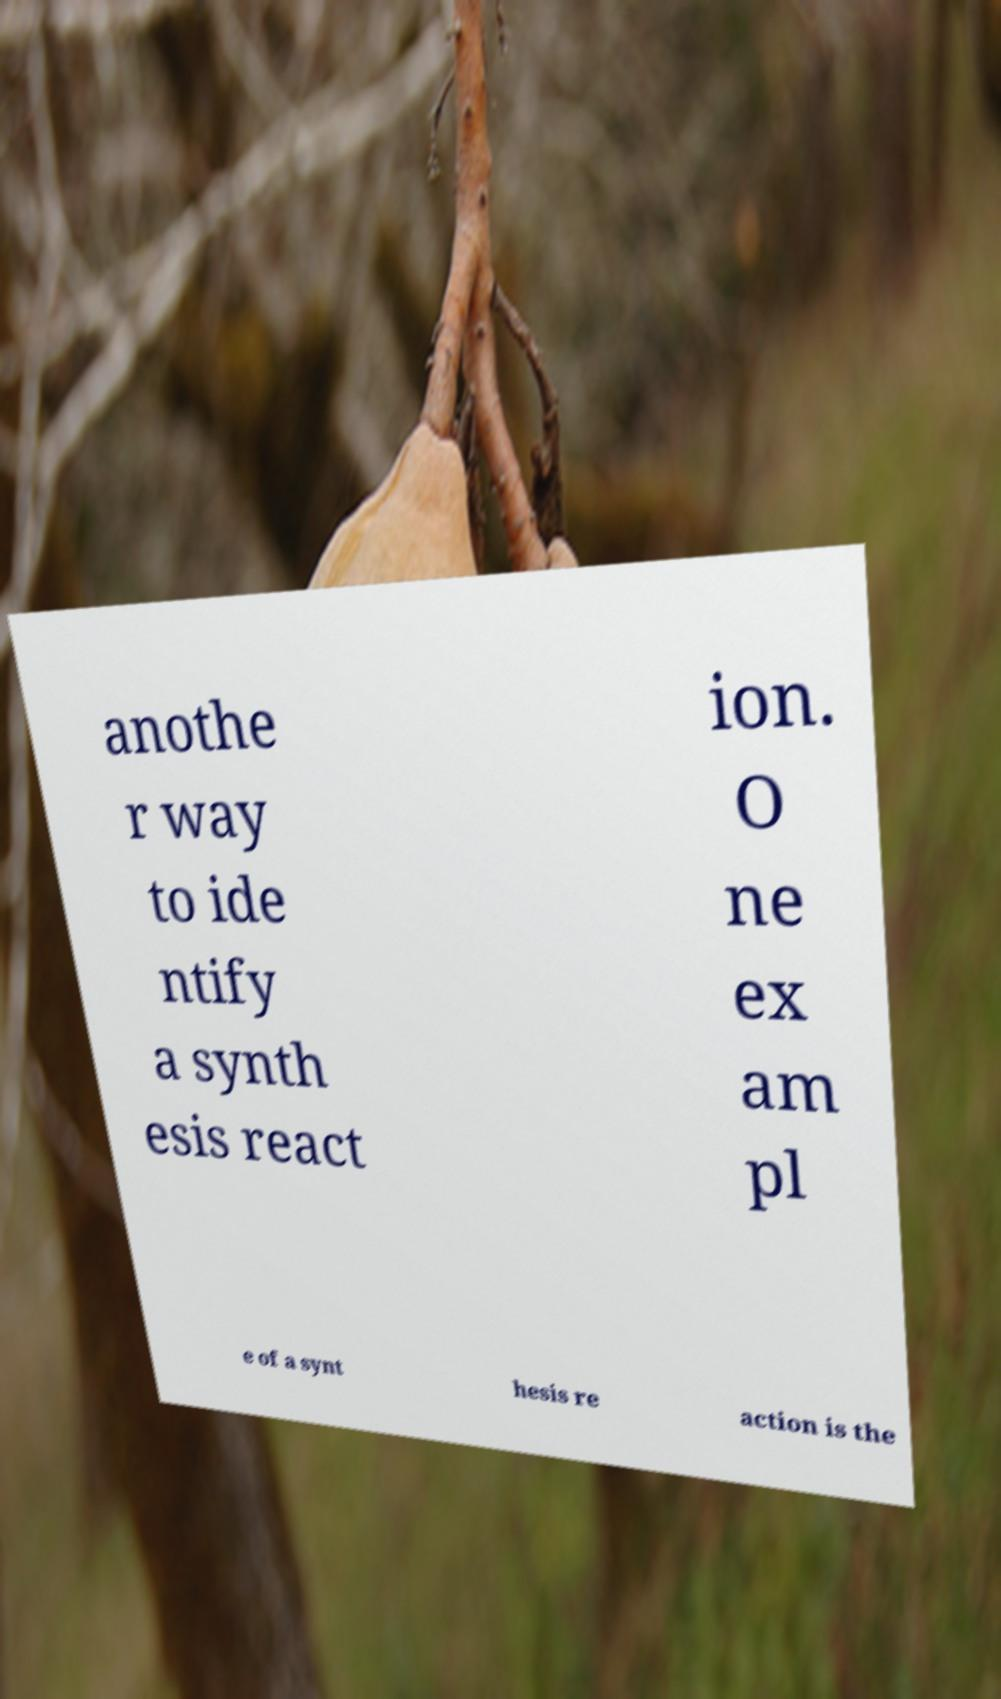Can you accurately transcribe the text from the provided image for me? anothe r way to ide ntify a synth esis react ion. O ne ex am pl e of a synt hesis re action is the 